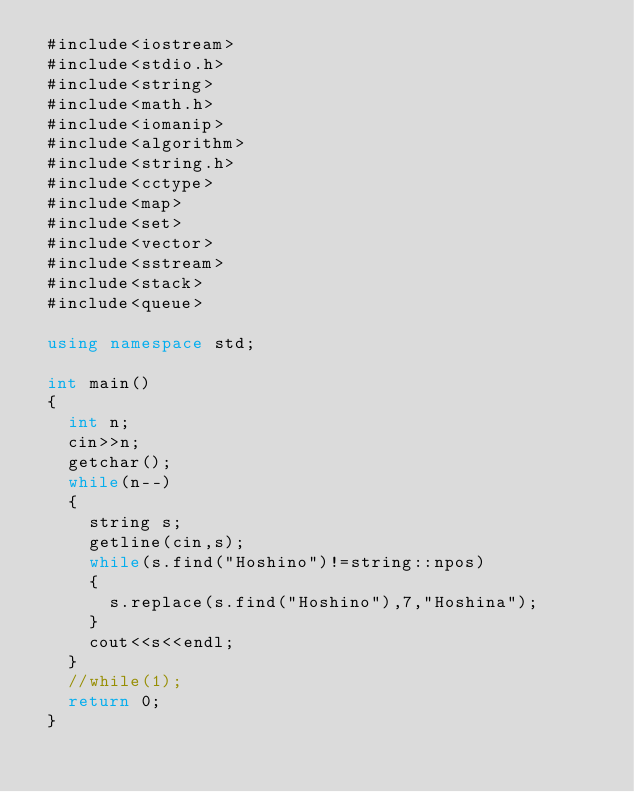<code> <loc_0><loc_0><loc_500><loc_500><_C++_> #include<iostream>
 #include<stdio.h>
 #include<string>
 #include<math.h>
 #include<iomanip>
 #include<algorithm>
 #include<string.h>
 #include<cctype>
 #include<map>
 #include<set>
 #include<vector>
 #include<sstream>
 #include<stack>
 #include<queue>
 
 using namespace std;
 
 int main()
 {
   int n;
   cin>>n;
   getchar();
   while(n--)
   {
     string s;
     getline(cin,s);
     while(s.find("Hoshino")!=string::npos)
     {
       s.replace(s.find("Hoshino"),7,"Hoshina");                                      
     }          
     cout<<s<<endl;
   }
   //while(1);
   return 0;
 }

 
 </code> 